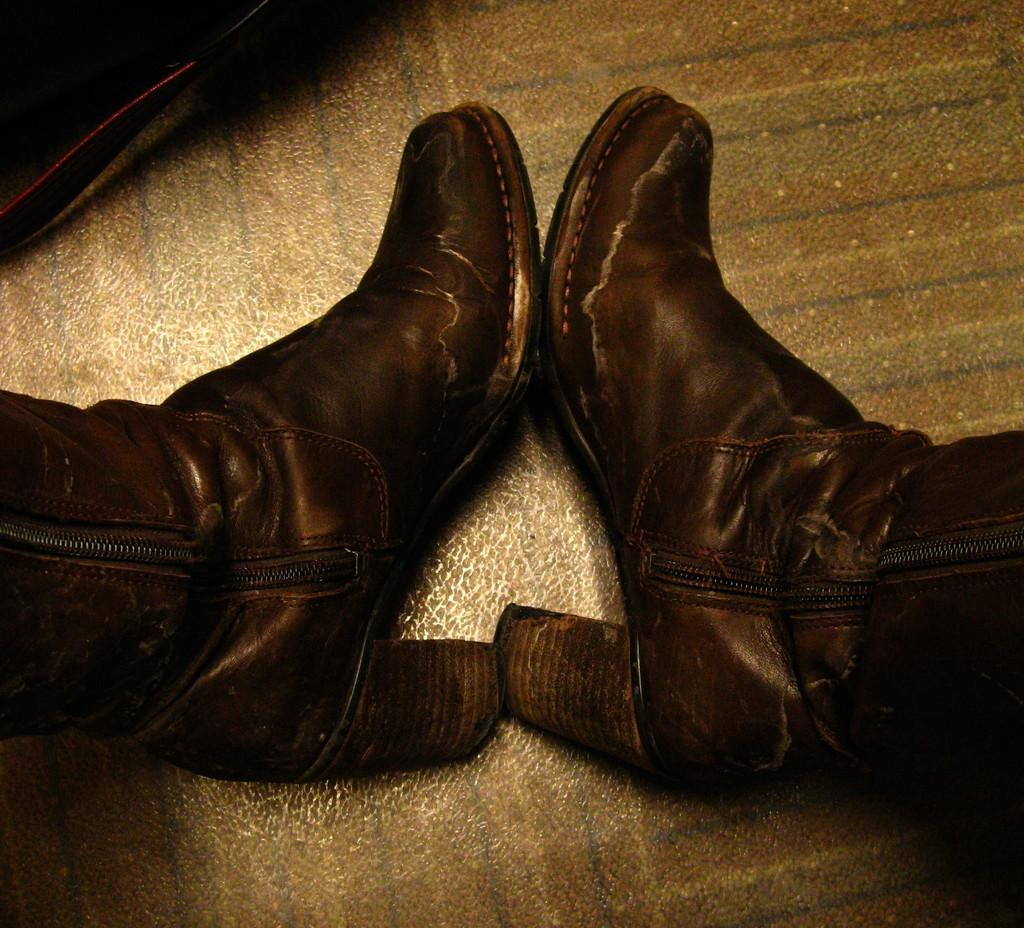What is the main subject in the center of the image? There are shoes in the center of the image. Where are the shoes located? The shoes are on the floor. What type of loss can be seen in the image? There is no loss visible in the image; it features shoes on the floor. What kind of crack is present in the image? There is no crack present in the image; it features shoes on the floor. 